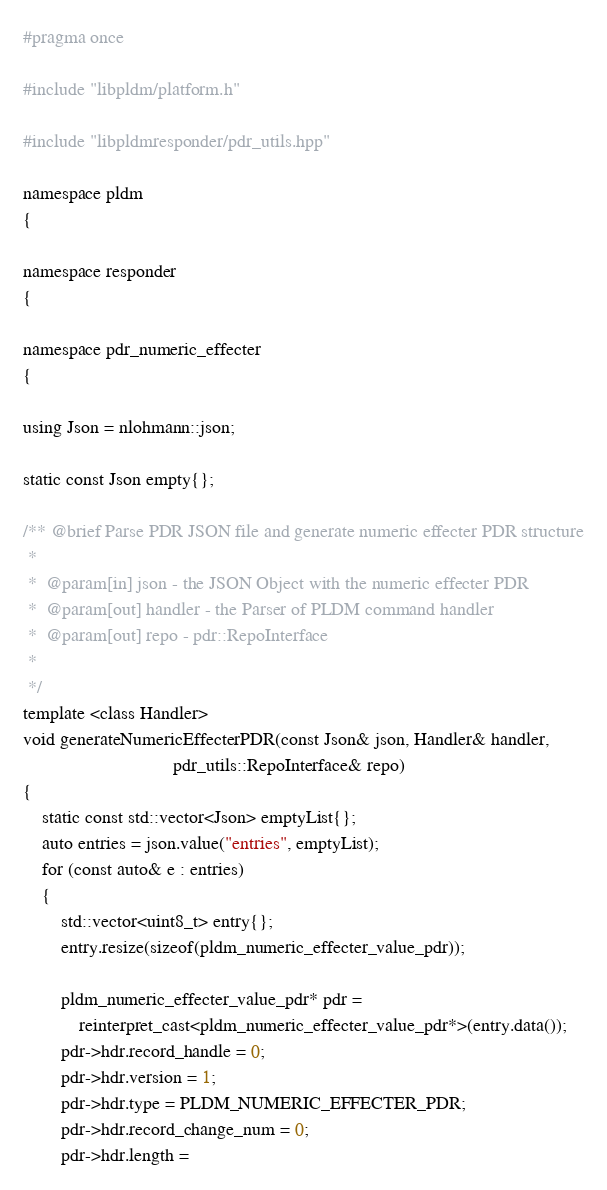Convert code to text. <code><loc_0><loc_0><loc_500><loc_500><_C++_>#pragma once

#include "libpldm/platform.h"

#include "libpldmresponder/pdr_utils.hpp"

namespace pldm
{

namespace responder
{

namespace pdr_numeric_effecter
{

using Json = nlohmann::json;

static const Json empty{};

/** @brief Parse PDR JSON file and generate numeric effecter PDR structure
 *
 *  @param[in] json - the JSON Object with the numeric effecter PDR
 *  @param[out] handler - the Parser of PLDM command handler
 *  @param[out] repo - pdr::RepoInterface
 *
 */
template <class Handler>
void generateNumericEffecterPDR(const Json& json, Handler& handler,
                                pdr_utils::RepoInterface& repo)
{
    static const std::vector<Json> emptyList{};
    auto entries = json.value("entries", emptyList);
    for (const auto& e : entries)
    {
        std::vector<uint8_t> entry{};
        entry.resize(sizeof(pldm_numeric_effecter_value_pdr));

        pldm_numeric_effecter_value_pdr* pdr =
            reinterpret_cast<pldm_numeric_effecter_value_pdr*>(entry.data());
        pdr->hdr.record_handle = 0;
        pdr->hdr.version = 1;
        pdr->hdr.type = PLDM_NUMERIC_EFFECTER_PDR;
        pdr->hdr.record_change_num = 0;
        pdr->hdr.length =</code> 